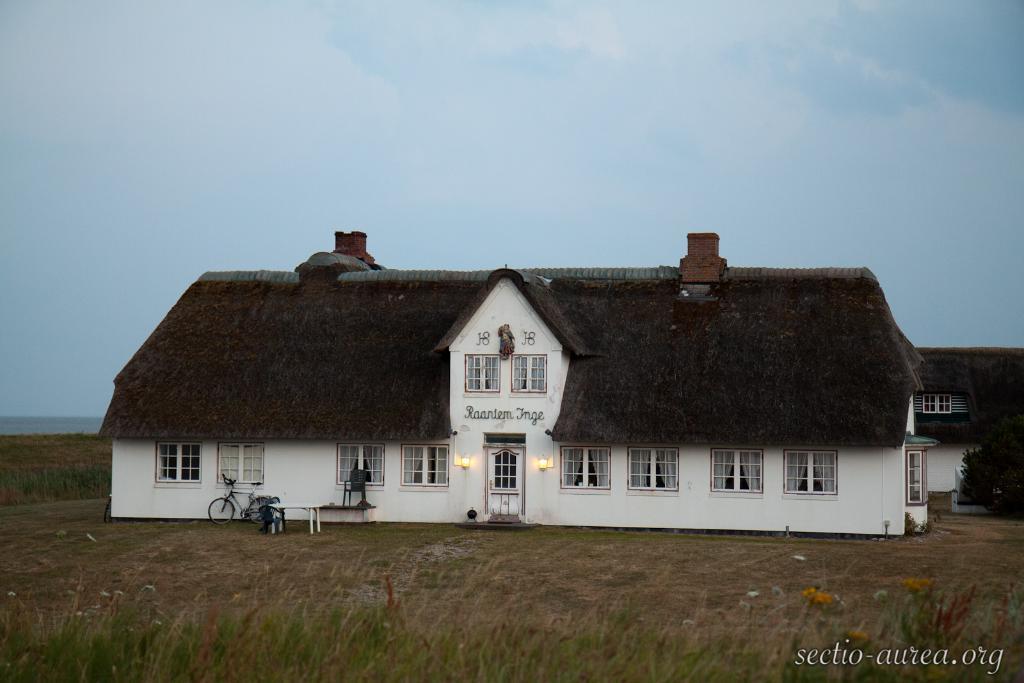Could you give a brief overview of what you see in this image? In the center of the image there are buildings. In front of the buildings there is a cycle. There is a table. In front of the image there are plants and flowers. In the background of the image there is sky. On the right side of the image there is a tree. There is some text on the right side of the image. 